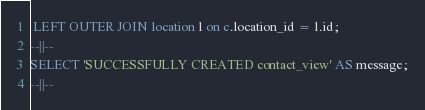Convert code to text. <code><loc_0><loc_0><loc_500><loc_500><_SQL_> LEFT OUTER JOIN location l on c.location_id = l.id;
--||--
SELECT 'SUCCESSFULLY CREATED contact_view' AS message;
--||--
</code> 